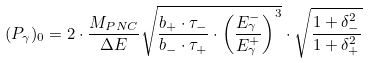<formula> <loc_0><loc_0><loc_500><loc_500>( P _ { \gamma } ) _ { 0 } = 2 \cdot \frac { M _ { P N C } } { \Delta E } \sqrt { \frac { b _ { + } \cdot \tau _ { - } } { b _ { - } \cdot \tau _ { + } } \cdot \left ( \frac { E ^ { - } _ { \gamma } } { E ^ { + } _ { \gamma } } \right ) ^ { 3 } } \cdot \sqrt { \frac { 1 + \delta ^ { 2 } _ { - } } { 1 + \delta ^ { 2 } _ { + } } }</formula> 